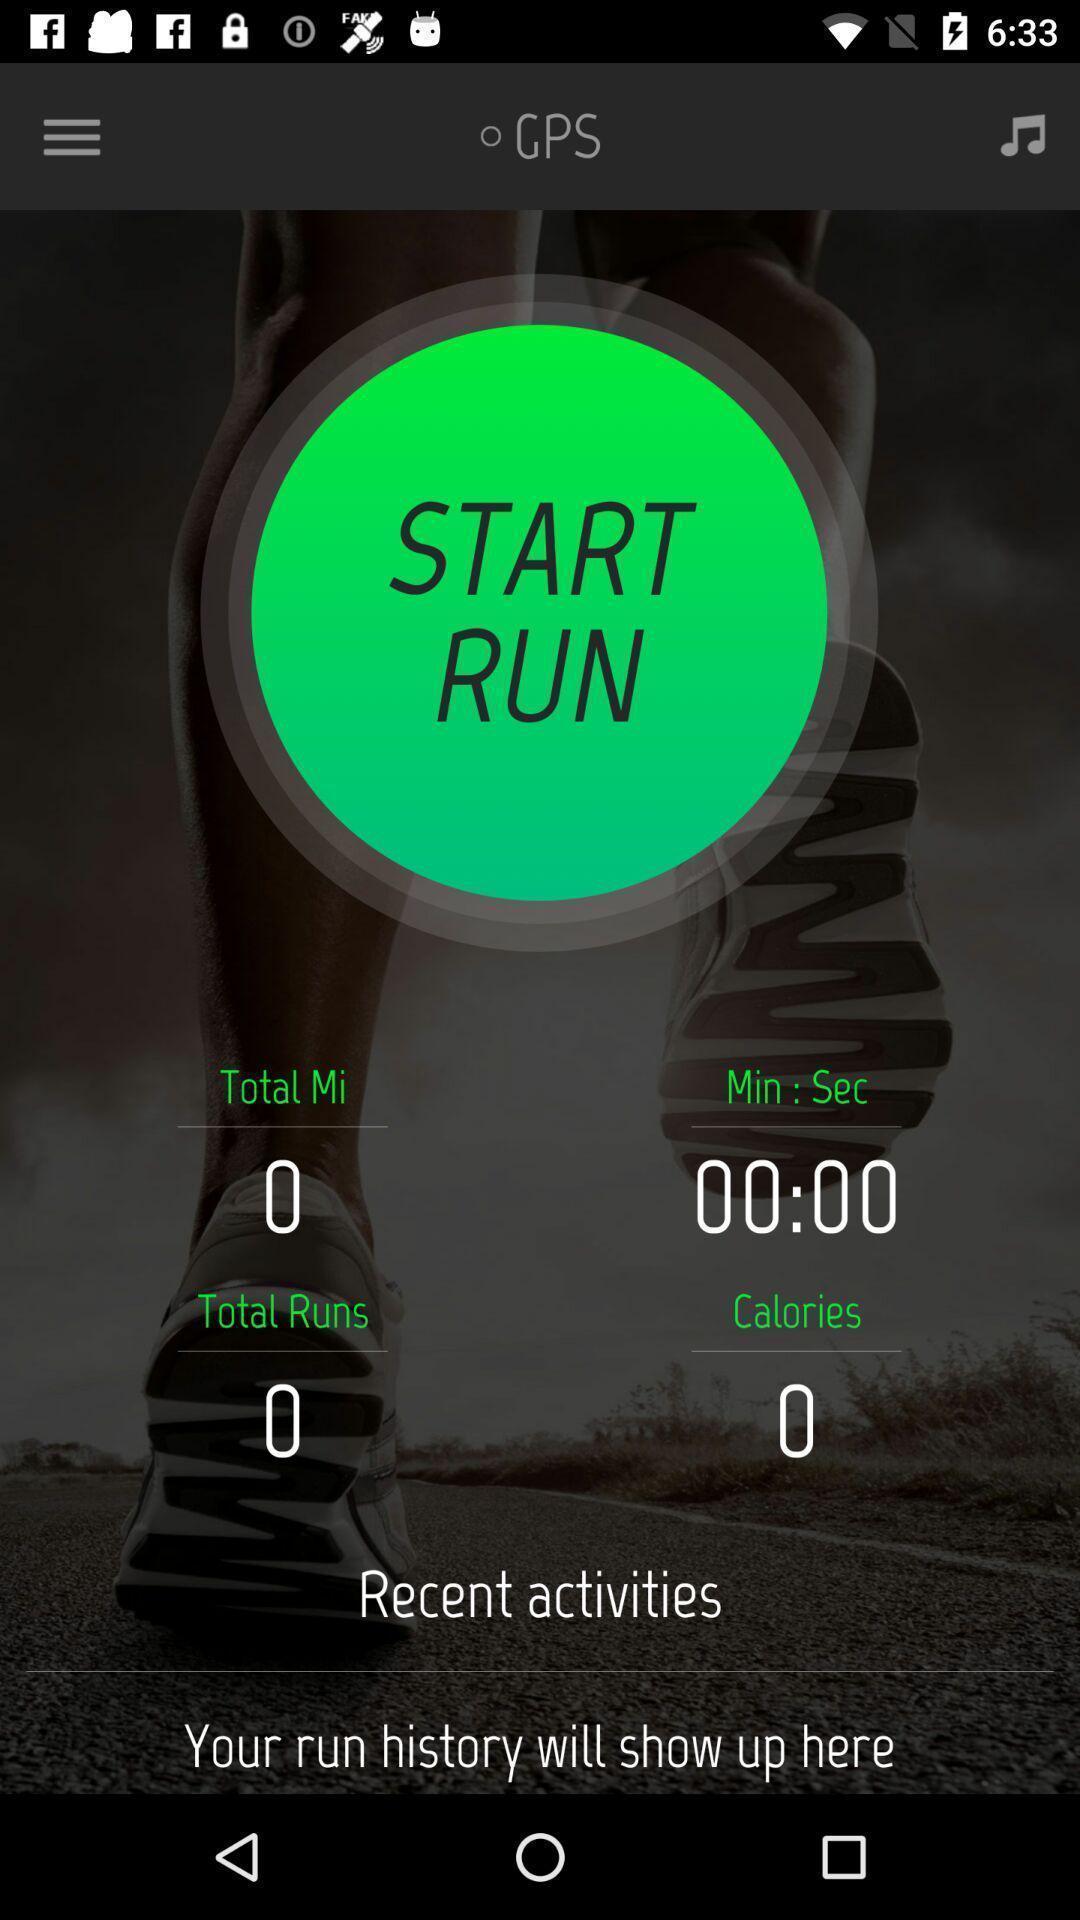Explain what's happening in this screen capture. Starting page. 